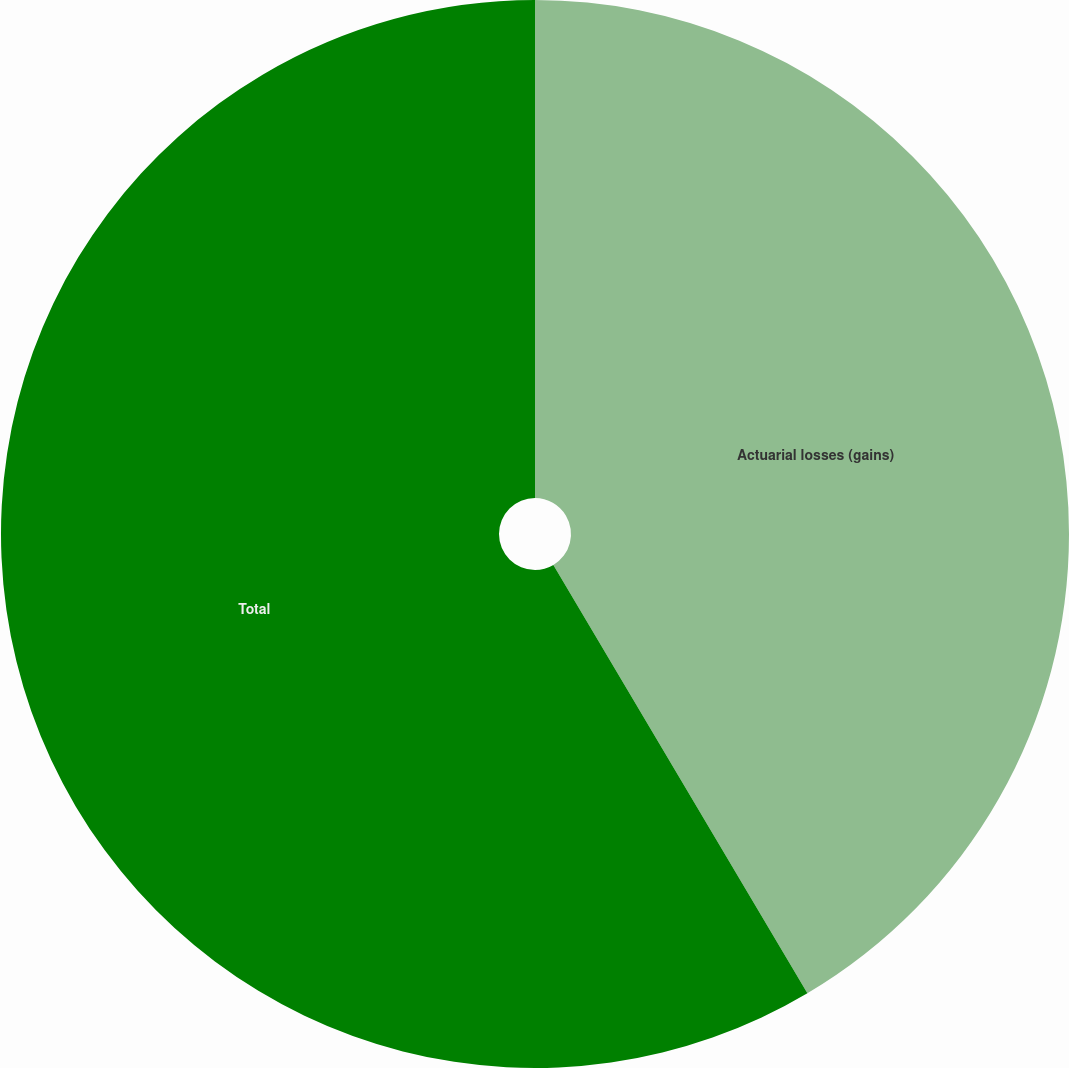Convert chart. <chart><loc_0><loc_0><loc_500><loc_500><pie_chart><fcel>Actuarial losses (gains)<fcel>Total<nl><fcel>41.48%<fcel>58.52%<nl></chart> 